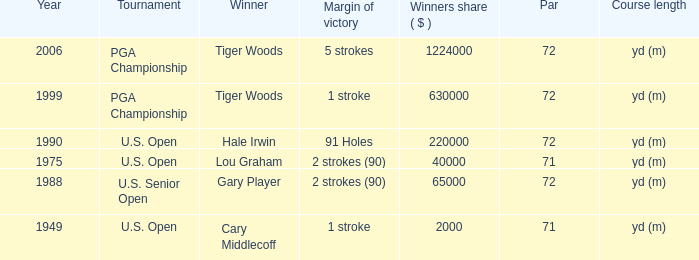When cary middlecoff is the winner how many pars are there? 1.0. 